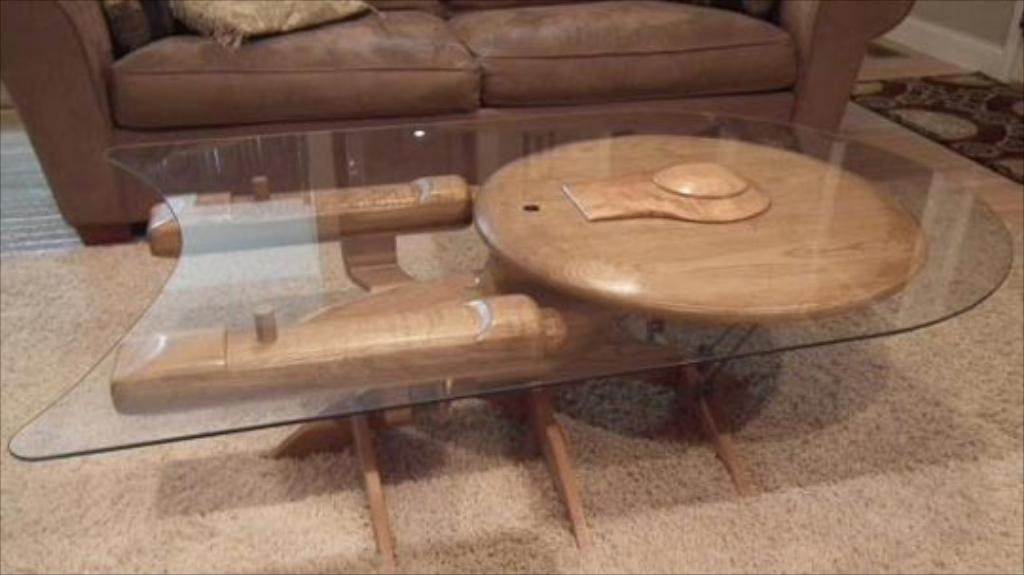What type of furniture is located at the top of the image? There is a sofa at the top of the image. What is the material of the table in the image? The table is made from glass. Where is the table positioned in the image? The table is in the middle of the image. What type of floor covering is at the bottom of the image? There is a carpet at the bottom of the image. What invention is being used to make a decision in the image? There is no invention or decision-making process depicted in the image; it features a sofa, a glass table, a carpet, and their respective positions. 